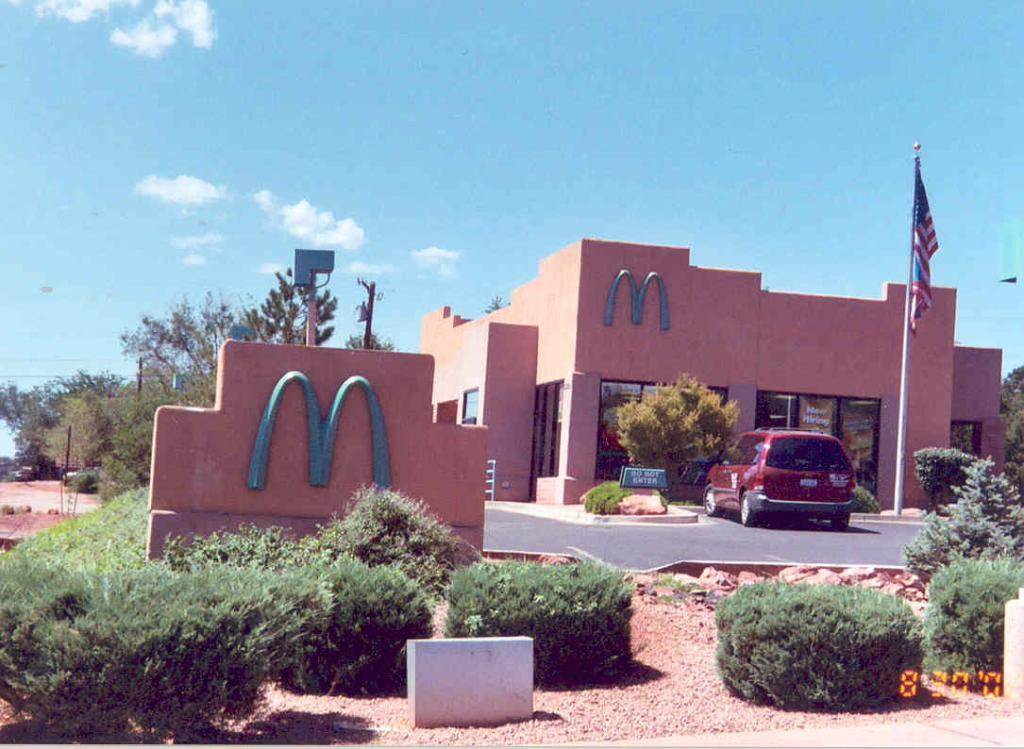What type of living organisms can be seen in the image? Plants can be seen in the image. What is on the wall in the image? There is a logo on a wall in the image. What can be seen in the background of the image? In the background of the image, there is a car on a pavement, a flag, a building, trees, and the sky. What type of straw is the queen using to sip her drink in the image? There is no queen or drink present in the image, so it is not possible to determine what type of straw she might be using. 